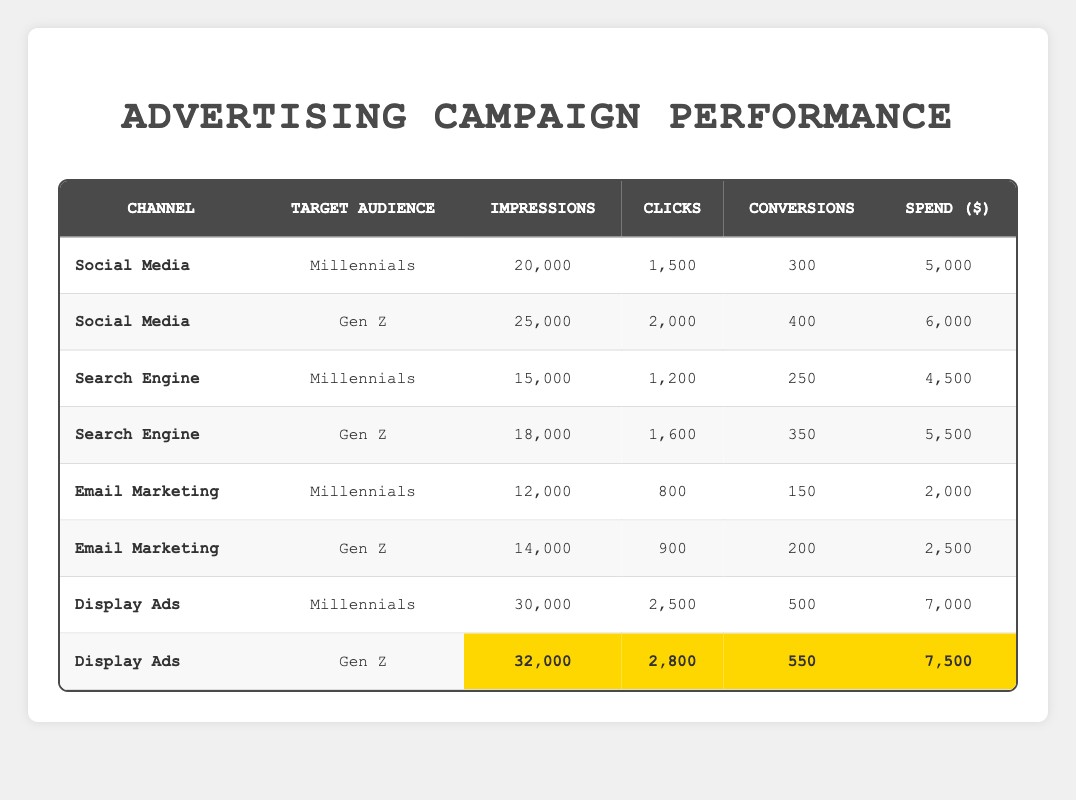What are the total impressions for Millennials across all channels? To calculate the total impressions for Millennials, we sum the impressions from the relevant rows: Social Media (20,000), Search Engine (15,000), Email Marketing (12,000), and Display Ads (30,000). So, the total is 20,000 + 15,000 + 12,000 + 30,000 = 77,000.
Answer: 77,000 Which channel and target audience generated the highest number of conversions? Looking at the conversions in the table, Social Media for Gen Z has 400, Display Ads for Gen Z has 550, and the other combinations have fewer conversions. Thus, Display Ads for Gen Z generated the highest at 550.
Answer: Display Ads, Gen Z Did the Search Engine channel perform better for Millennials than for Gen Z in terms of conversions? For Millennials, the Search Engine generated 250 conversions, while for Gen Z, it generated 350 conversions. Since 250 is less than 350, the Search Engine did not perform better for Millennials than for Gen Z regarding conversions.
Answer: No What is the total spend on Email Marketing for both target audiences combined? To find the total spend on Email Marketing, we add the spend amounts from the relevant rows: Millennials at $2,000 and Gen Z at $2,500. The total is 2,000 + 2,500 = 4,500.
Answer: 4,500 What percentage of impressions led to conversions for Display Ads targeting Gen Z? The number of conversions for Display Ads targeting Gen Z is 550, and the impressions are 32,000. To find the conversion percentage, we divide 550 by 32,000 and multiply by 100. Therefore, the calculation is (550 / 32,000) * 100 = 1.72%.
Answer: 1.72% Which target audience had a higher average number of clicks across all channels? First, we need the total clicks for each target audience: Millennials: (1,500 + 1,200 + 800 + 2,500) = 6,000 total clicks across 4 channels, giving an average of 6,000 / 4 = 1,500 clicks. Gen Z: (2,000 + 1,600 + 900 + 2,800) = 7,300 total clicks across 4 channels, resulting in an average of 7,300 / 4 = 1,825 clicks. Gen Z has a higher average at 1,825.
Answer: Gen Z Did both Social Media and Display Ads have more total clicks than the Email Marketing channel? Total clicks for Social Media are 1,500 (Millennials) + 2,000 (Gen Z) = 3,500. Total clicks for Display Ads are 2,500 (Millennials) + 2,800 (Gen Z) = 5,300. Total clicks for Email Marketing are 800 (Millennials) + 900 (Gen Z) = 1,700. The combined clicks for Social Media and Display Ads (3,500 + 5,300 = 8,800) exceed Email Marketing's total of 1,700.
Answer: Yes What is the difference in conversions between the highest and lowest performing channels for Millennials? The highest conversions for Millennials came from Display Ads at 500, while the lowest was from Email Marketing at 150. The difference is 500 - 150 = 350.
Answer: 350 